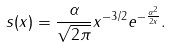Convert formula to latex. <formula><loc_0><loc_0><loc_500><loc_500>s ( x ) = \frac { \alpha } { \sqrt { 2 \pi } } x ^ { - 3 / 2 } e ^ { - \frac { \alpha ^ { 2 } } { 2 x } } .</formula> 